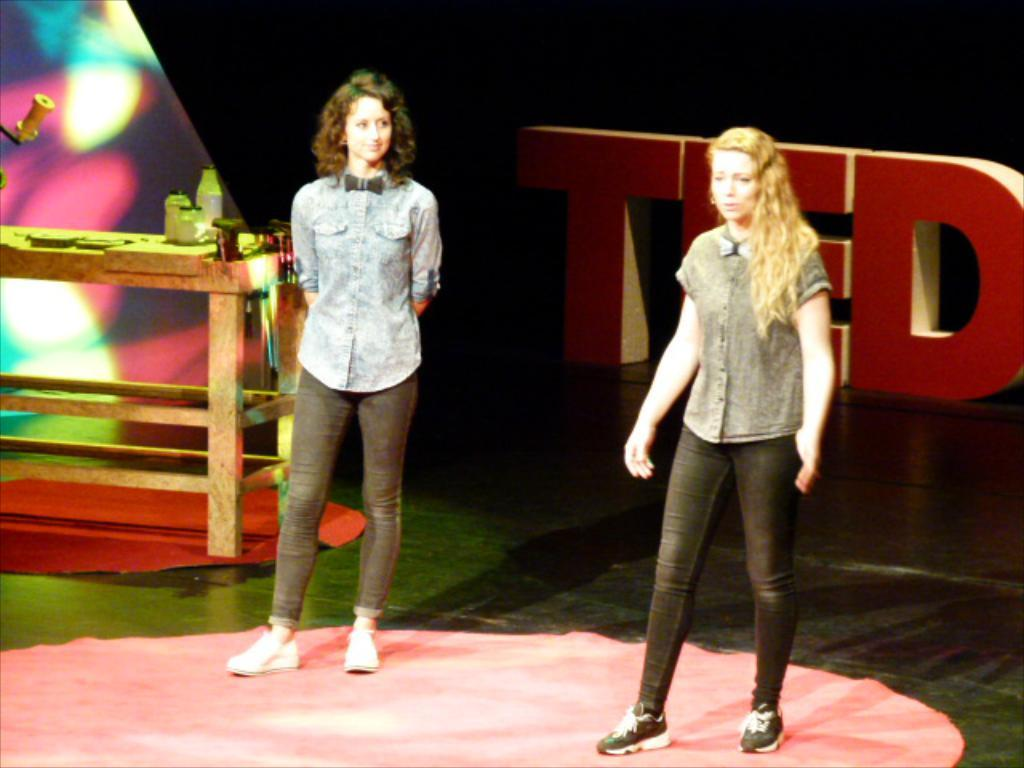How many women are in the image? There are two women in the image. What are the women doing in the image? The women are standing on the floor. What are the women wearing in the image? The women are wearing shirts, pants, and shoes. What is present in the image besides the women? There is a table with bottles and other objects on it, and there is text visible in the background of the image. What time of day is it in the image, and how does the chain fall from the table? The time of day is not mentioned in the image, and there is no chain present to fall from the table. 